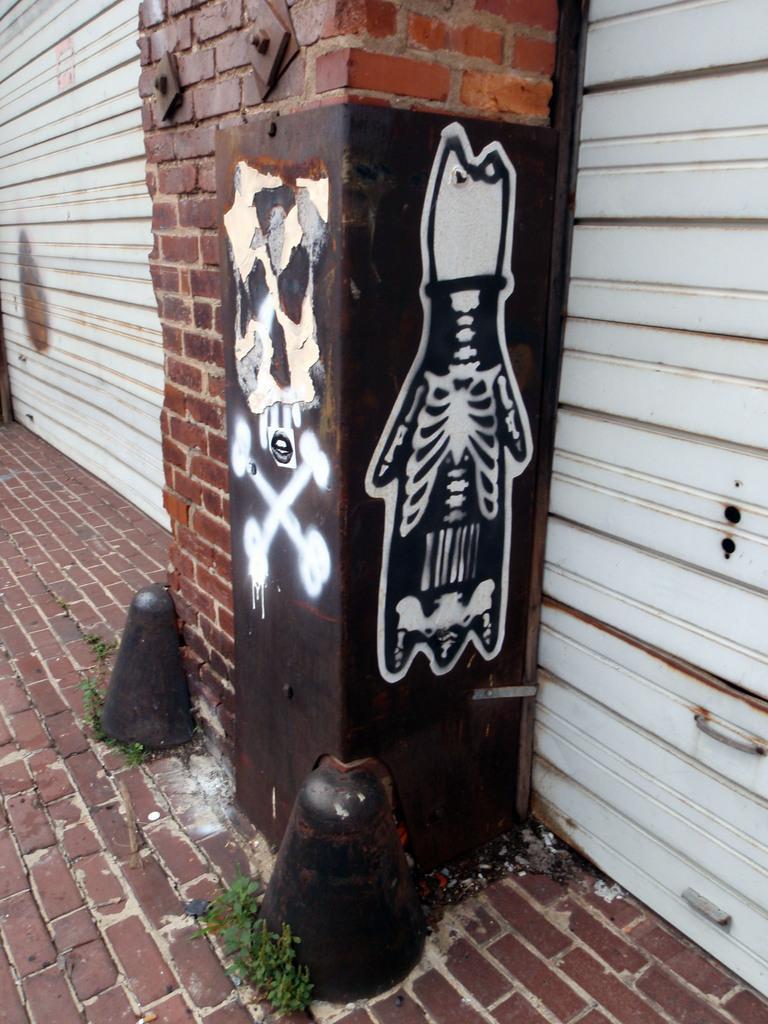How would you summarize this image in a sentence or two? In this image we can see few shutters. There is a painting on the metal object. There are few plants in the image. There is a pillar in the image. 